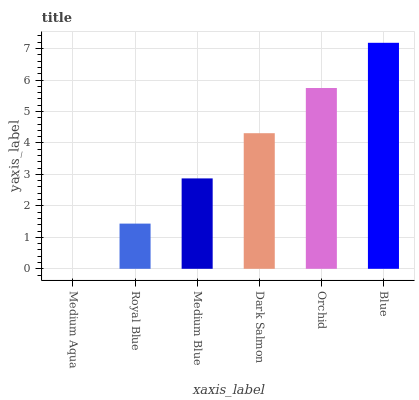Is Medium Aqua the minimum?
Answer yes or no. Yes. Is Blue the maximum?
Answer yes or no. Yes. Is Royal Blue the minimum?
Answer yes or no. No. Is Royal Blue the maximum?
Answer yes or no. No. Is Royal Blue greater than Medium Aqua?
Answer yes or no. Yes. Is Medium Aqua less than Royal Blue?
Answer yes or no. Yes. Is Medium Aqua greater than Royal Blue?
Answer yes or no. No. Is Royal Blue less than Medium Aqua?
Answer yes or no. No. Is Dark Salmon the high median?
Answer yes or no. Yes. Is Medium Blue the low median?
Answer yes or no. Yes. Is Blue the high median?
Answer yes or no. No. Is Blue the low median?
Answer yes or no. No. 